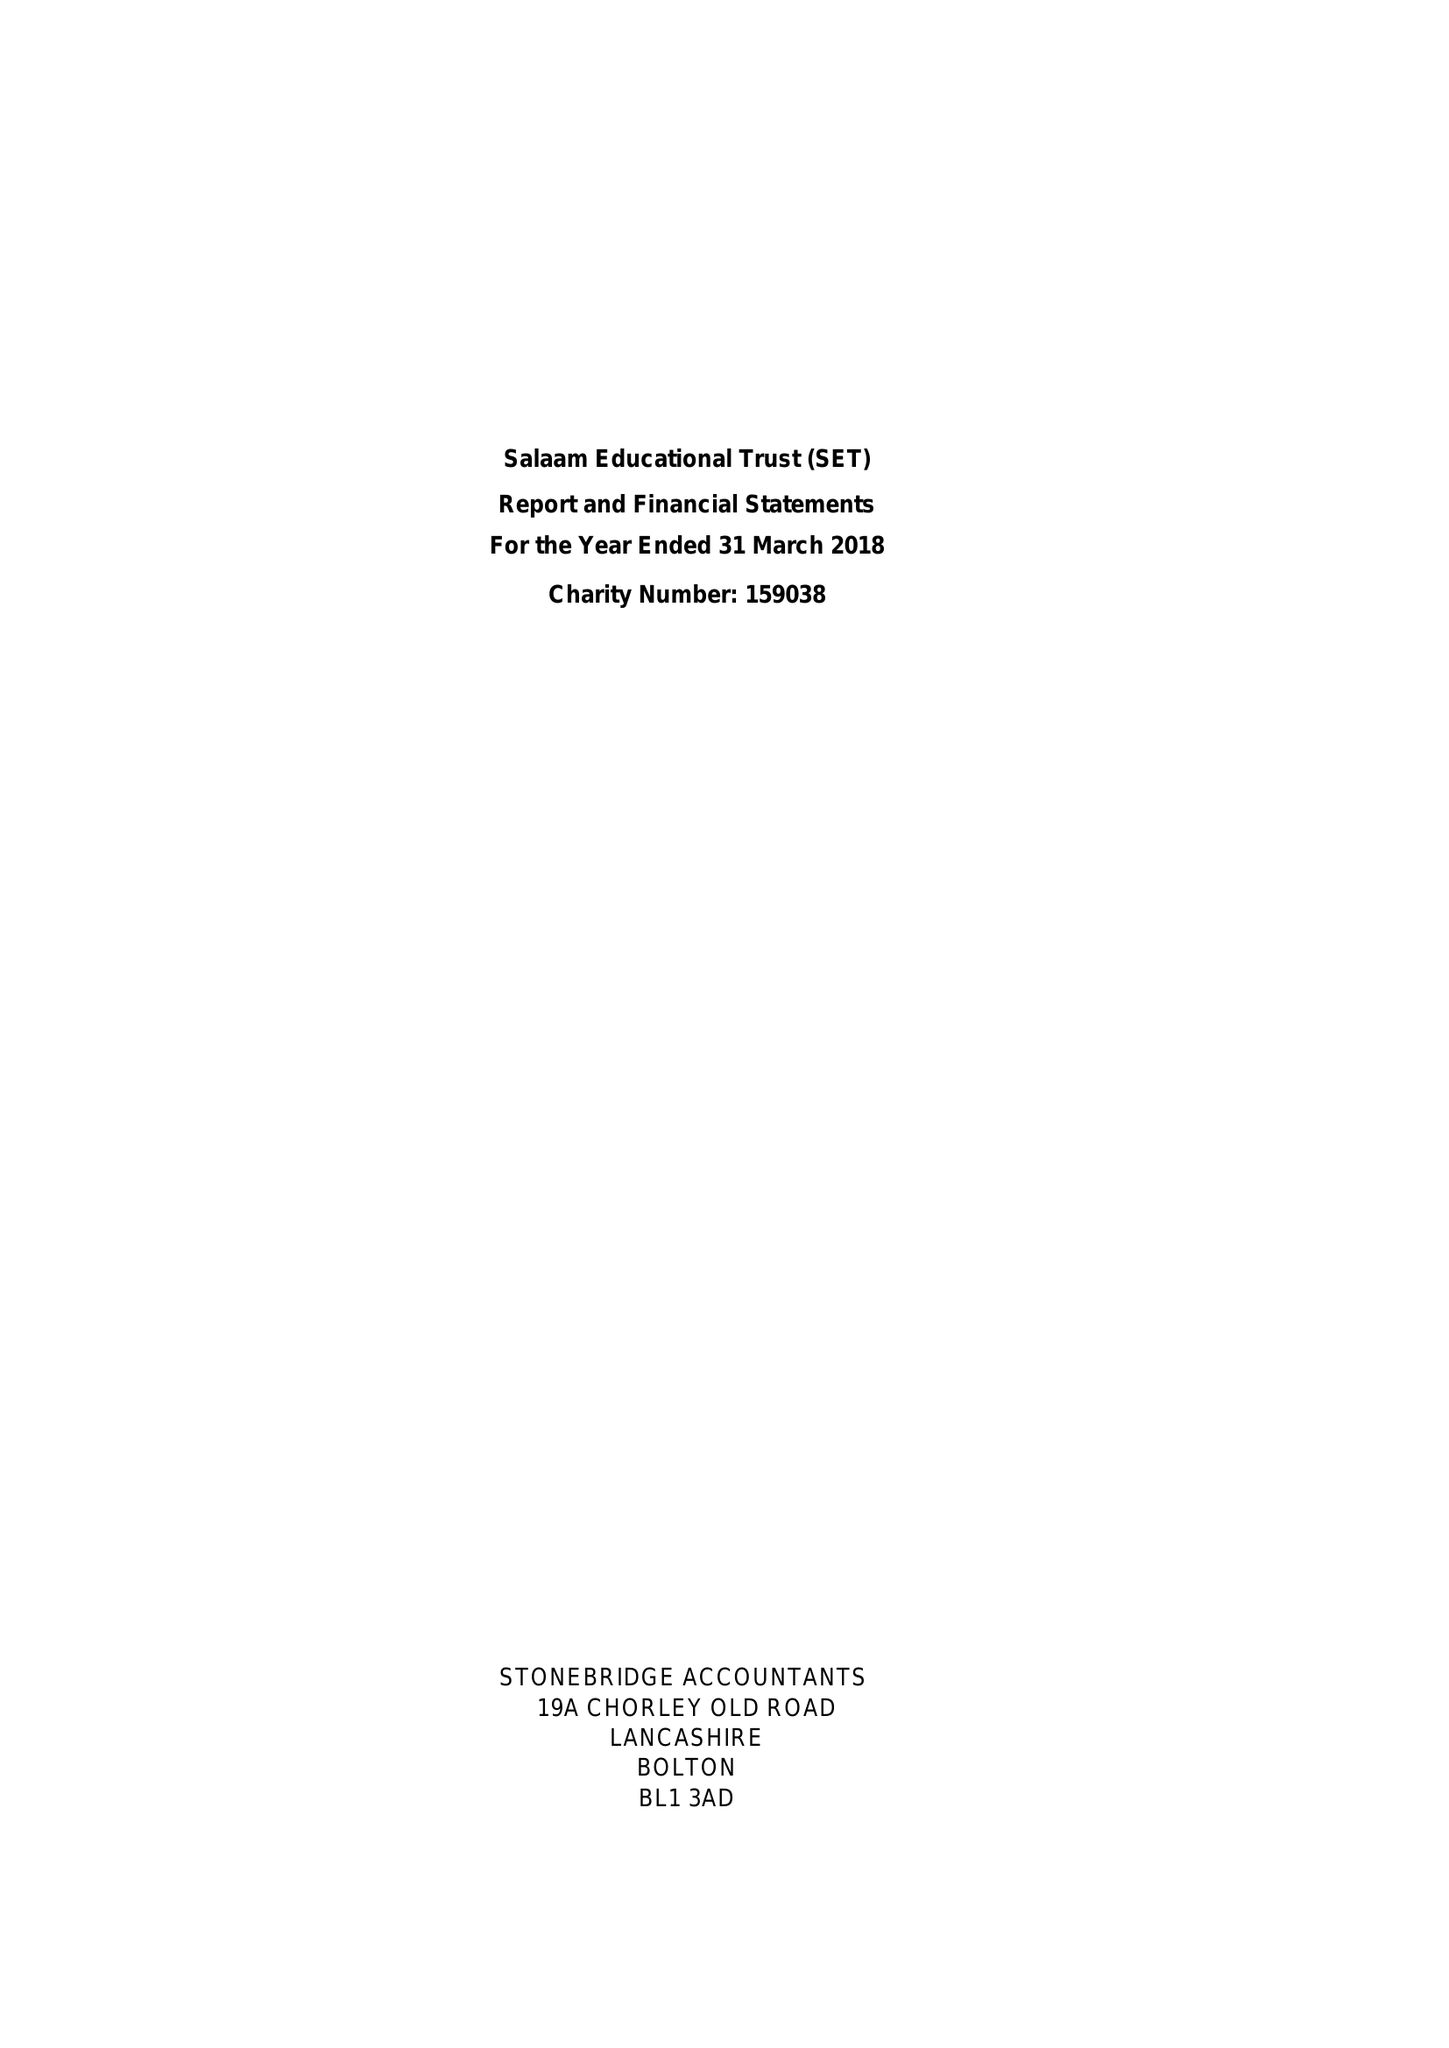What is the value for the report_date?
Answer the question using a single word or phrase. 2018-03-31 